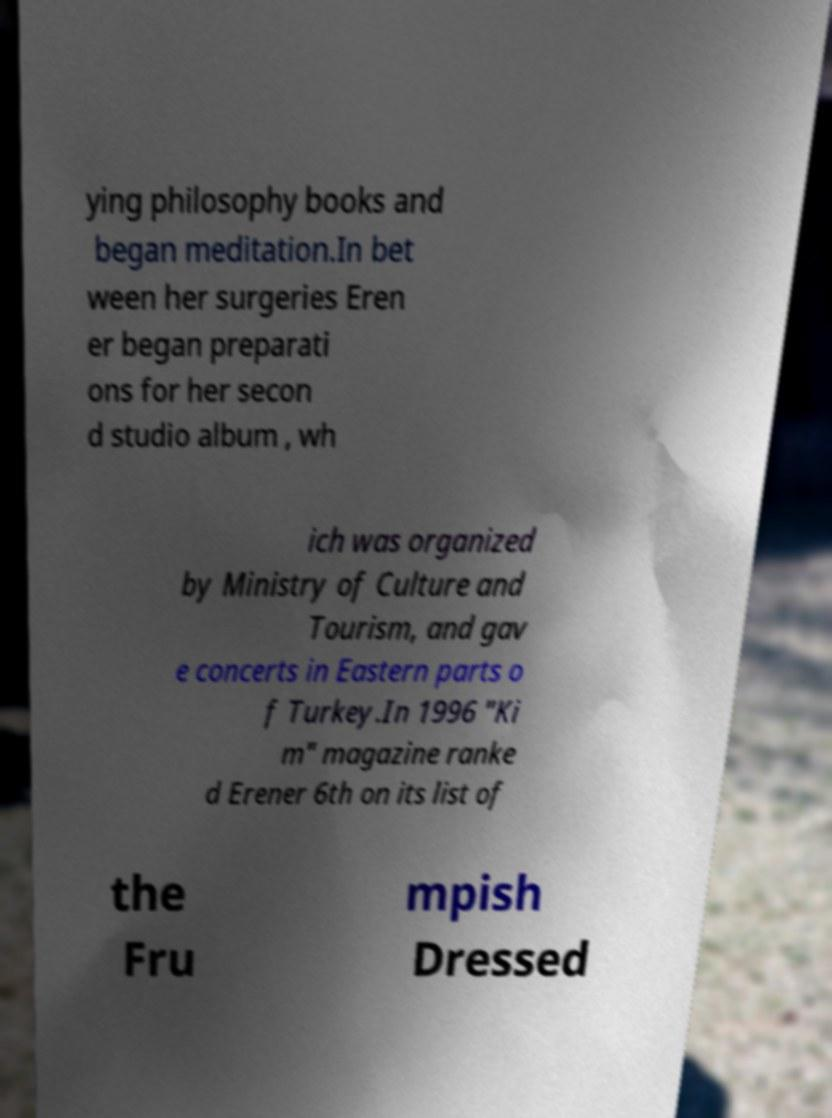Please read and relay the text visible in this image. What does it say? ying philosophy books and began meditation.In bet ween her surgeries Eren er began preparati ons for her secon d studio album , wh ich was organized by Ministry of Culture and Tourism, and gav e concerts in Eastern parts o f Turkey.In 1996 "Ki m" magazine ranke d Erener 6th on its list of the Fru mpish Dressed 